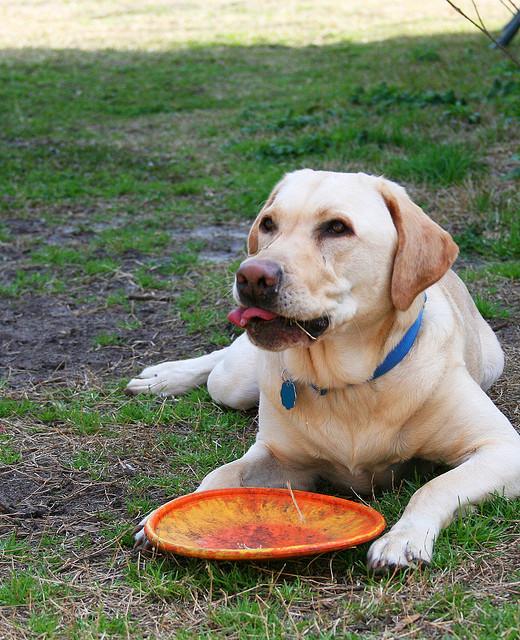What is the color of the collar on the dog?
Give a very brief answer. Blue. What shape is the dogs tag?
Keep it brief. Circle. What is the orange item?
Keep it brief. Frisbee. Is the dog's tongue out?
Quick response, please. Yes. Is the dog able to eat this old Frisbee?
Short answer required. No. What color is the collar?
Answer briefly. Blue. What type of dog is in the picture?
Answer briefly. Lab. What is in the dog's dish?
Short answer required. Nothing. What color is the frisbee?
Quick response, please. Orange. What color is the dog?
Be succinct. Tan. 